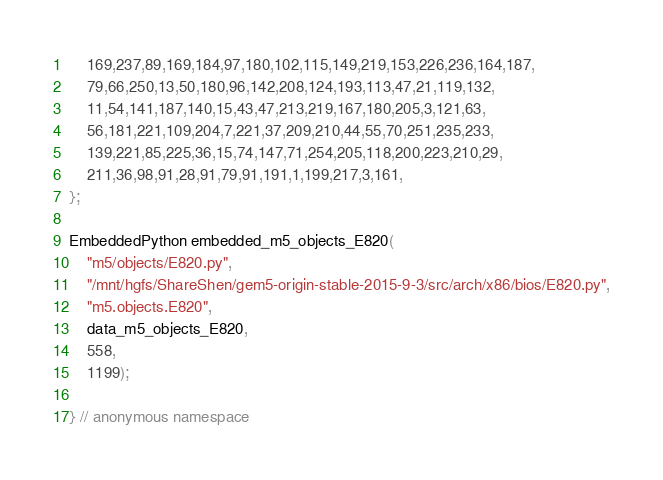<code> <loc_0><loc_0><loc_500><loc_500><_C++_>    169,237,89,169,184,97,180,102,115,149,219,153,226,236,164,187,
    79,66,250,13,50,180,96,142,208,124,193,113,47,21,119,132,
    11,54,141,187,140,15,43,47,213,219,167,180,205,3,121,63,
    56,181,221,109,204,7,221,37,209,210,44,55,70,251,235,233,
    139,221,85,225,36,15,74,147,71,254,205,118,200,223,210,29,
    211,36,98,91,28,91,79,91,191,1,199,217,3,161,
};

EmbeddedPython embedded_m5_objects_E820(
    "m5/objects/E820.py",
    "/mnt/hgfs/ShareShen/gem5-origin-stable-2015-9-3/src/arch/x86/bios/E820.py",
    "m5.objects.E820",
    data_m5_objects_E820,
    558,
    1199);

} // anonymous namespace
</code> 